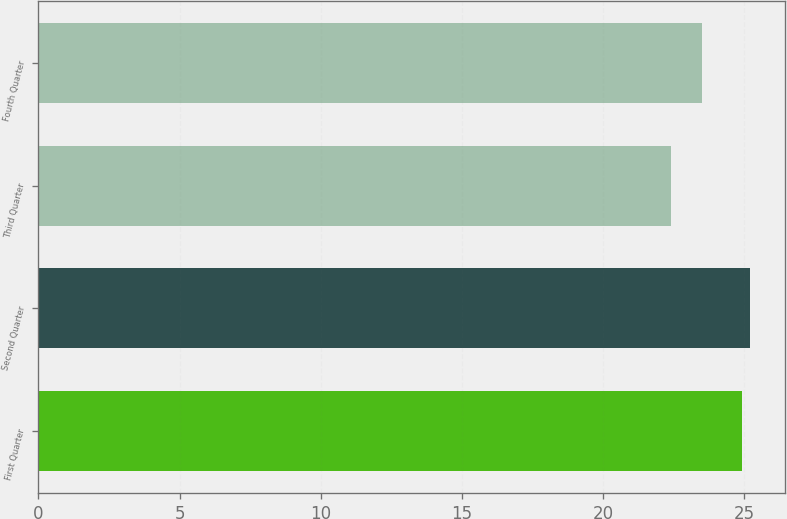Convert chart to OTSL. <chart><loc_0><loc_0><loc_500><loc_500><bar_chart><fcel>First Quarter<fcel>Second Quarter<fcel>Third Quarter<fcel>Fourth Quarter<nl><fcel>24.94<fcel>25.2<fcel>22.41<fcel>23.5<nl></chart> 